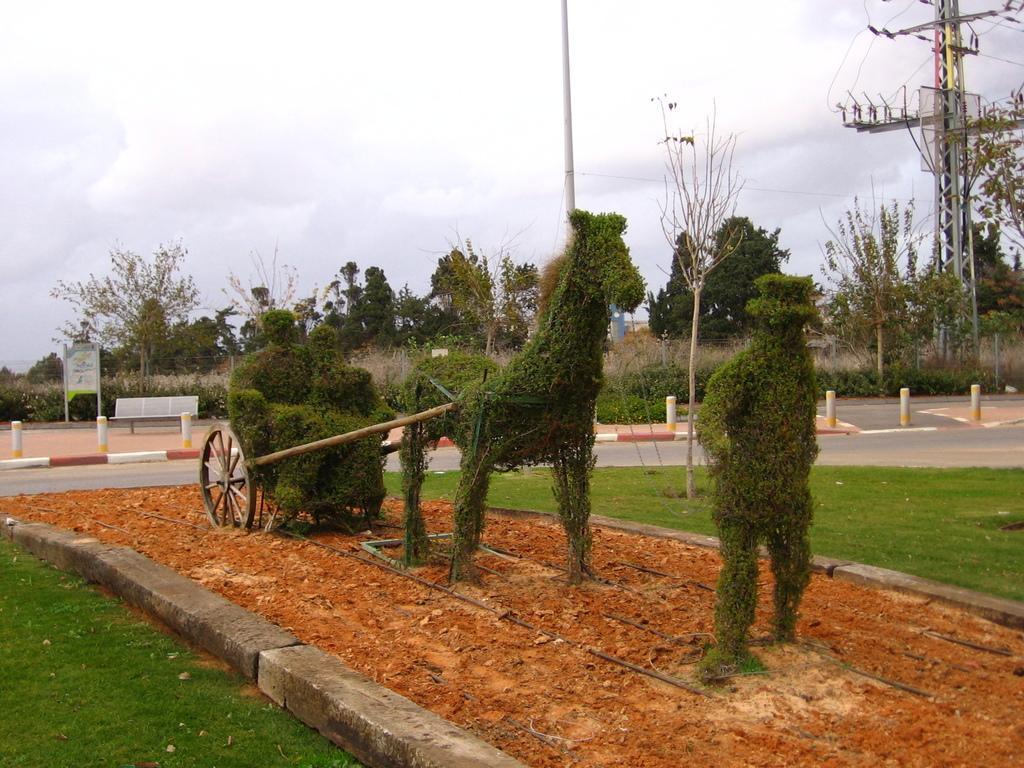Could you give a brief overview of what you see in this image? In the center of the image we can see plants. In the background we can see road, trees, poles, sky and clouds. 